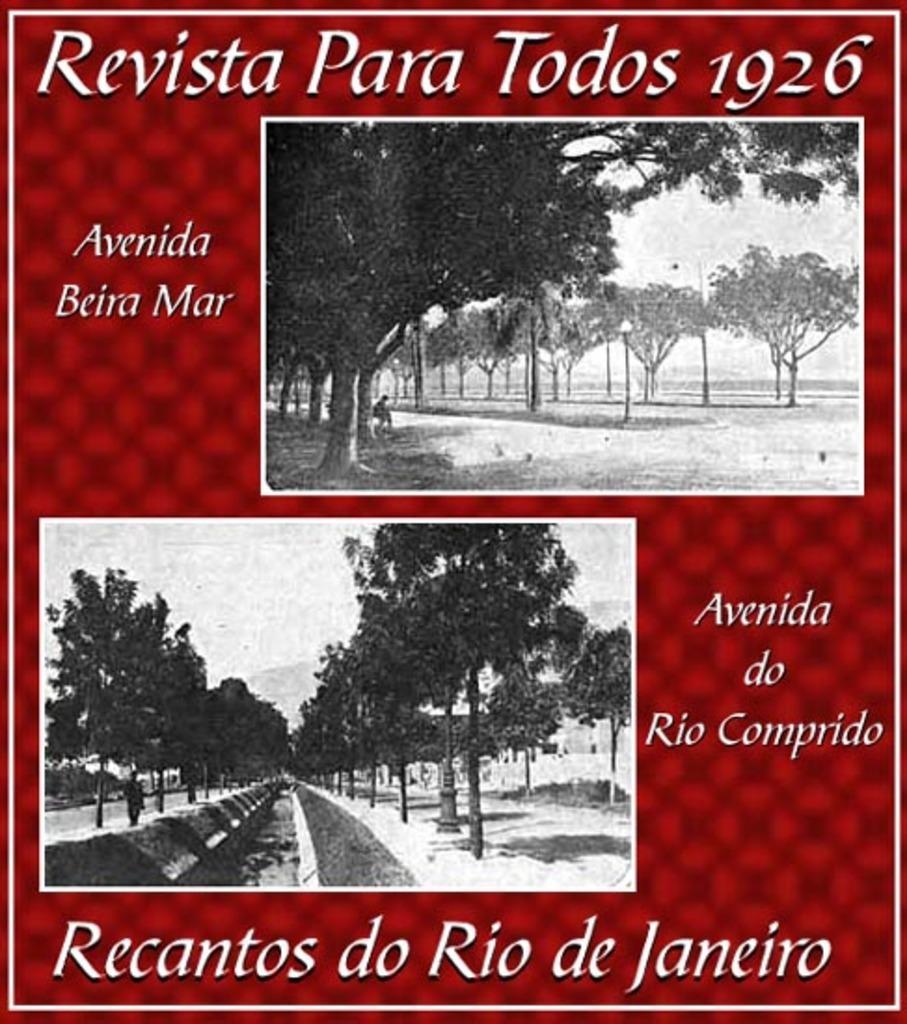Describe this image in one or two sentences. This is a collage image, and here we can see trees and we can see a person. 